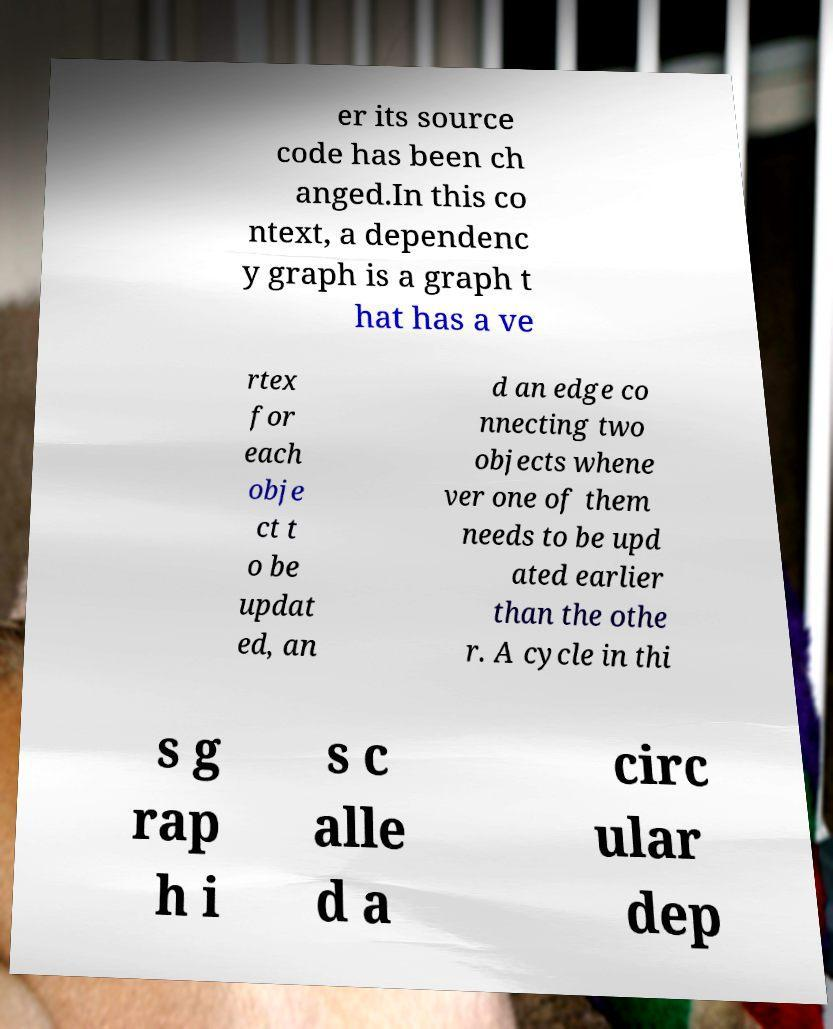What messages or text are displayed in this image? I need them in a readable, typed format. er its source code has been ch anged.In this co ntext, a dependenc y graph is a graph t hat has a ve rtex for each obje ct t o be updat ed, an d an edge co nnecting two objects whene ver one of them needs to be upd ated earlier than the othe r. A cycle in thi s g rap h i s c alle d a circ ular dep 